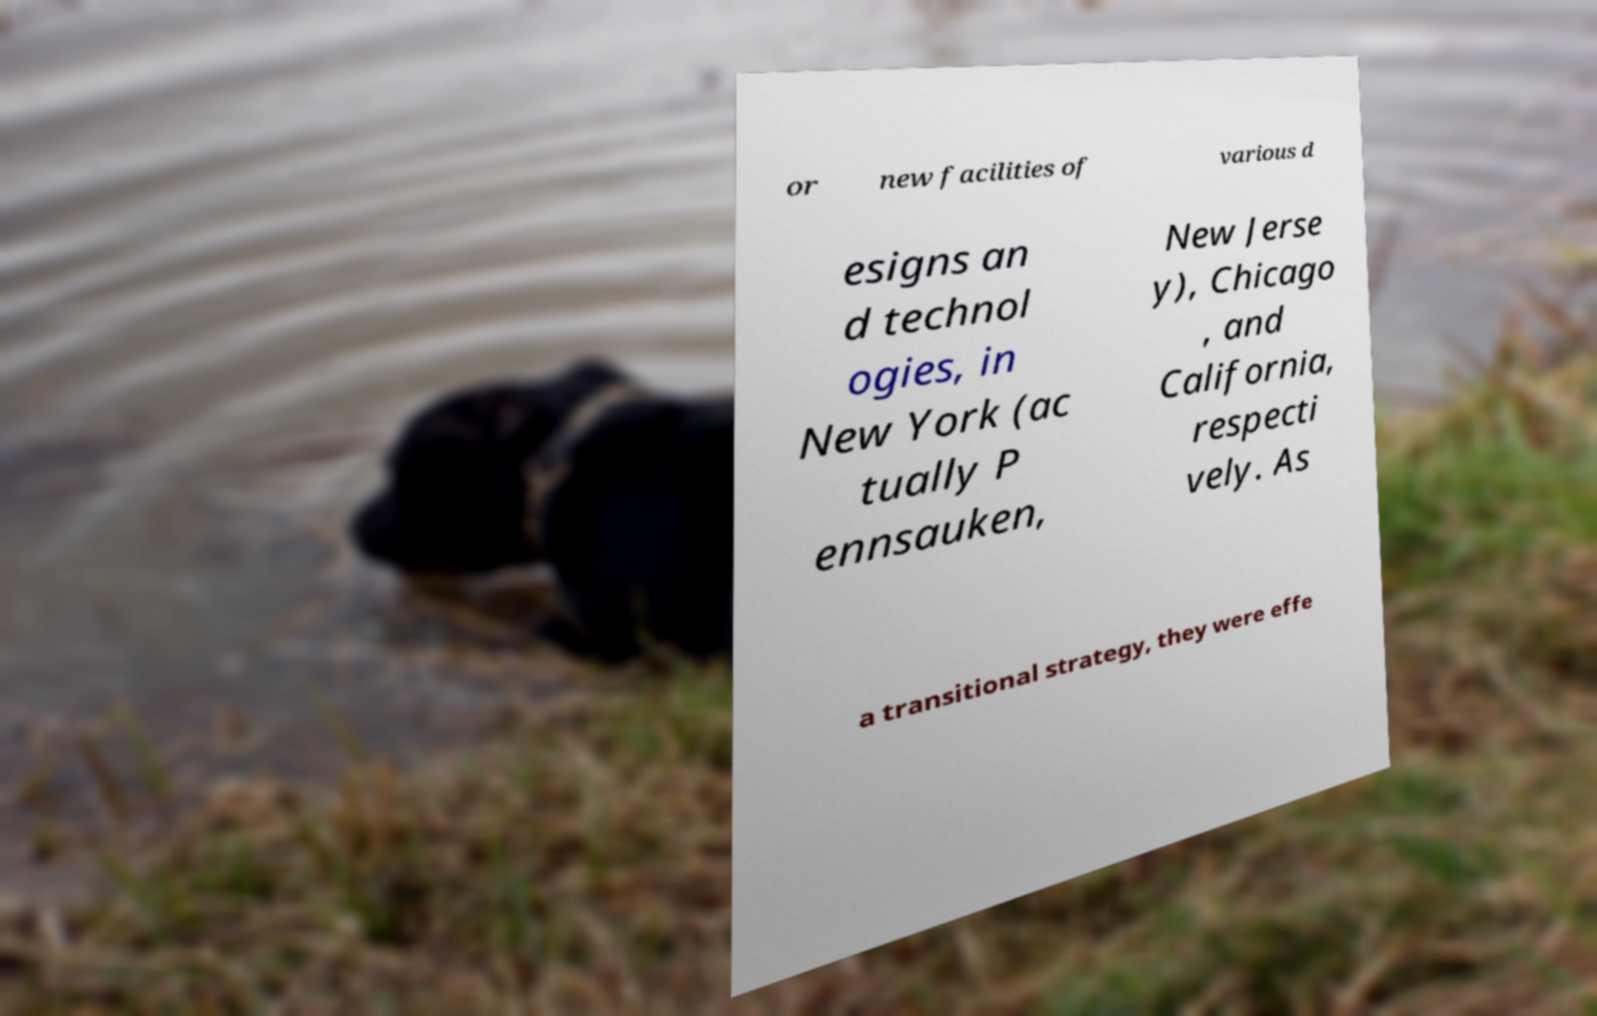There's text embedded in this image that I need extracted. Can you transcribe it verbatim? or new facilities of various d esigns an d technol ogies, in New York (ac tually P ennsauken, New Jerse y), Chicago , and California, respecti vely. As a transitional strategy, they were effe 